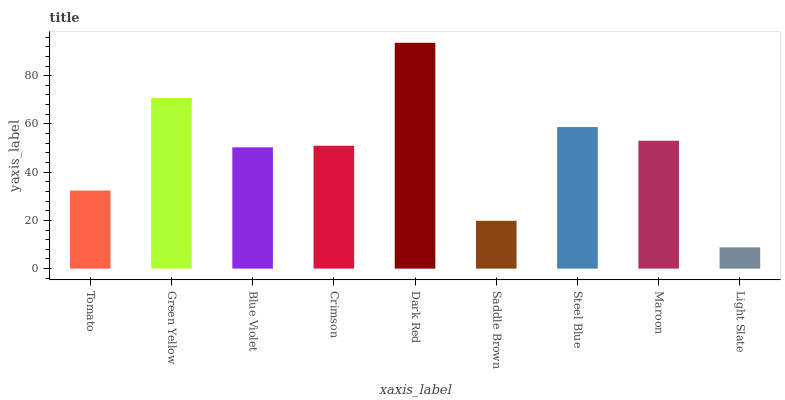Is Light Slate the minimum?
Answer yes or no. Yes. Is Dark Red the maximum?
Answer yes or no. Yes. Is Green Yellow the minimum?
Answer yes or no. No. Is Green Yellow the maximum?
Answer yes or no. No. Is Green Yellow greater than Tomato?
Answer yes or no. Yes. Is Tomato less than Green Yellow?
Answer yes or no. Yes. Is Tomato greater than Green Yellow?
Answer yes or no. No. Is Green Yellow less than Tomato?
Answer yes or no. No. Is Crimson the high median?
Answer yes or no. Yes. Is Crimson the low median?
Answer yes or no. Yes. Is Green Yellow the high median?
Answer yes or no. No. Is Tomato the low median?
Answer yes or no. No. 